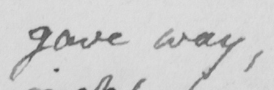What is written in this line of handwriting? gave way  , 